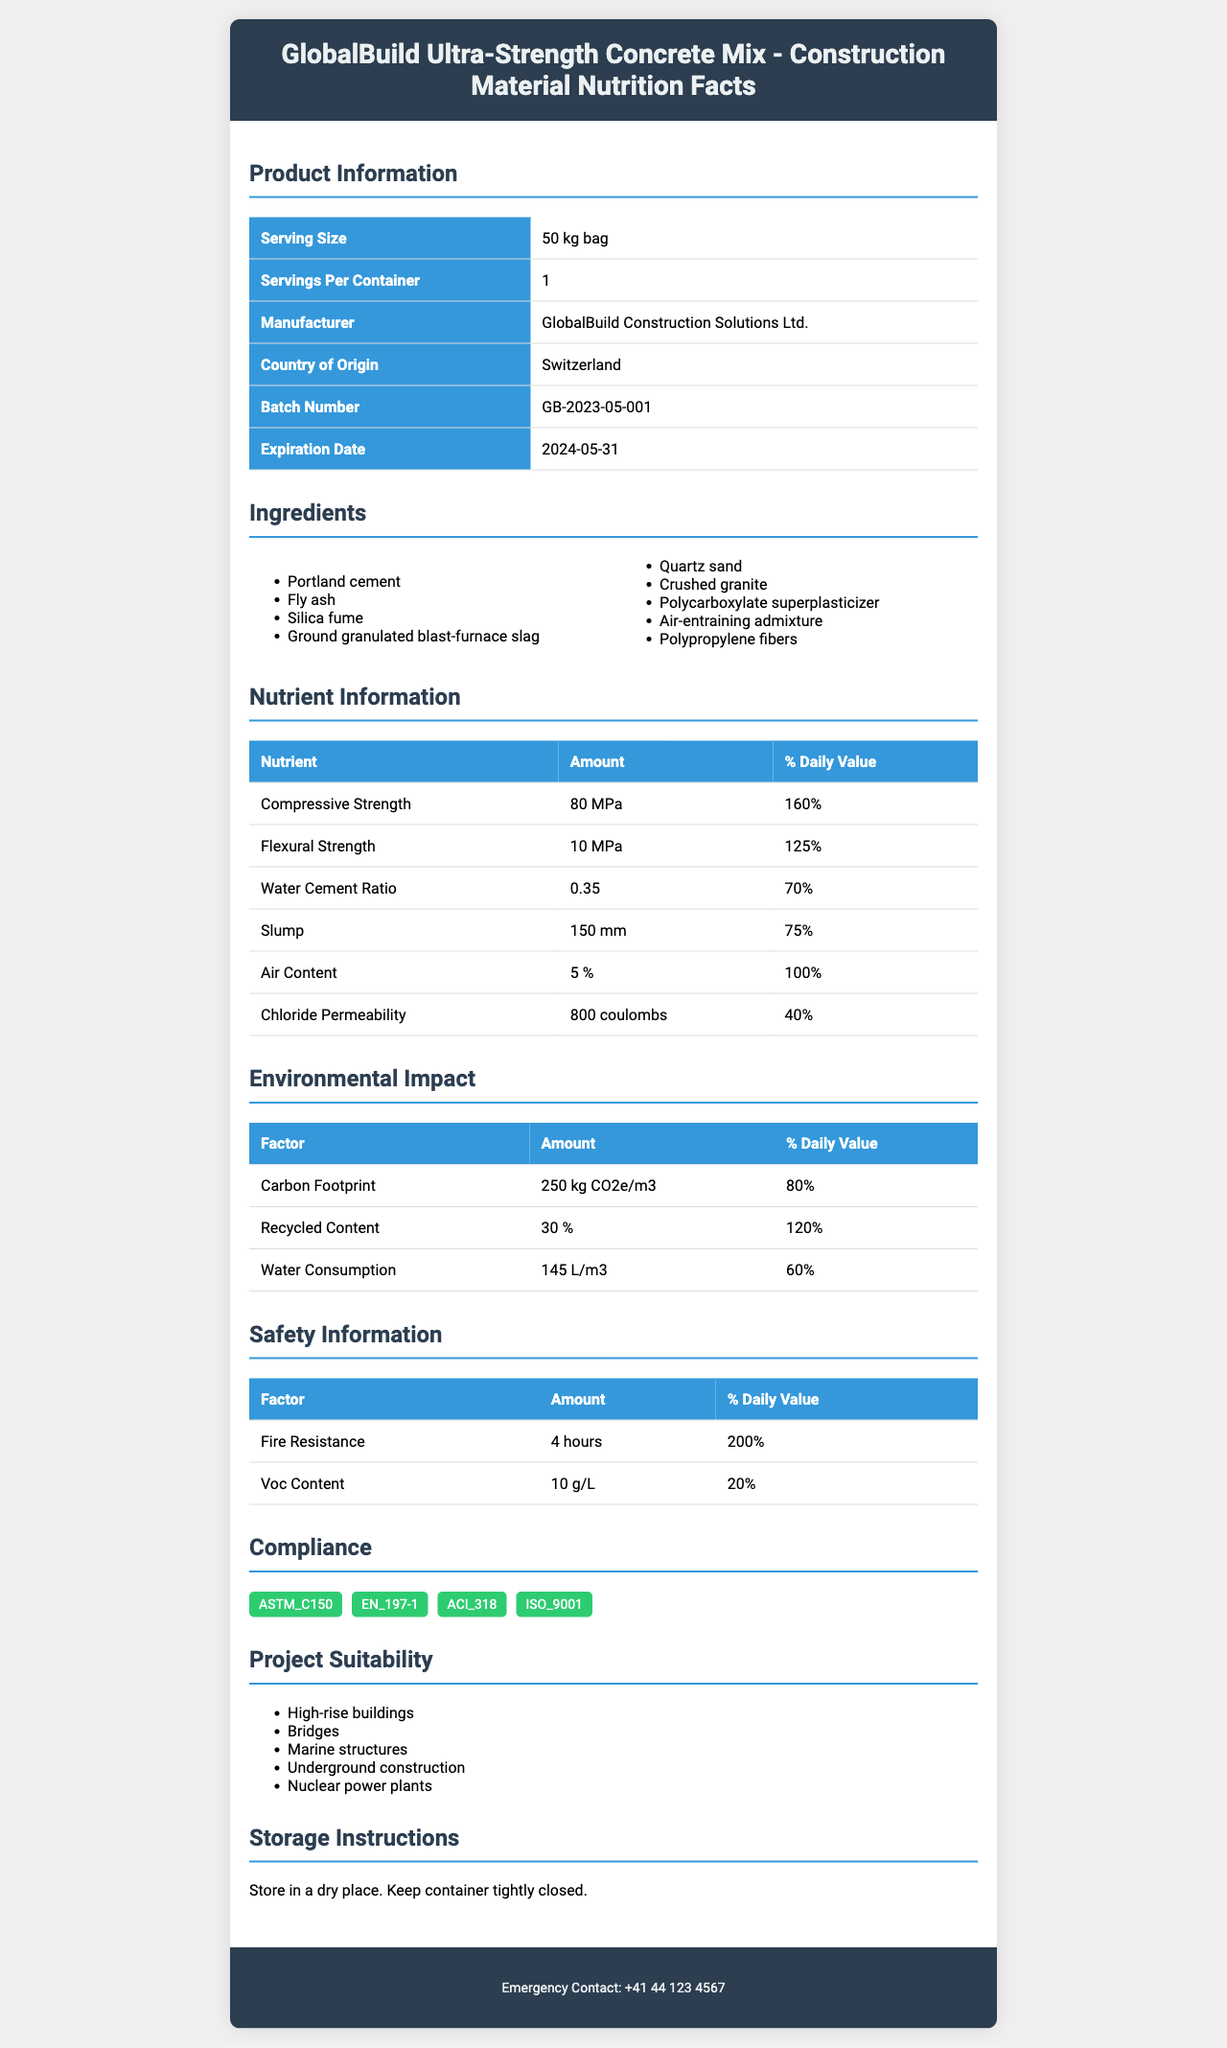what is the serving size of the GlobalBuild Ultra-Strength Concrete Mix? The serving size is listed as "50 kg bag" in the product information section.
Answer: 50 kg bag how many servings are there per container? The document states that there is 1 serving per container.
Answer: 1 name three ingredients used in the GlobalBuild Ultra-Strength Concrete Mix. The document lists the ingredients, and three of them include Portland cement, Fly ash, and Silica fume.
Answer: Portland cement, Fly ash, Silica fume what is the compressive strength value and its unit? The compressive strength value is 80, and the unit is MPa as mentioned in the nutrient information section.
Answer: 80 MPa what is the batch number of the product? The batch number is listed as "GB-2023-05-001" in the product information section.
Answer: GB-2023-05-001 how much recycled content is there, and what percentage of the daily value does it represent? The recycled content is 30%, representing 120% of the daily value.
Answer: 30%, 120% which factors are included in the environmental impact section? These factors are listed under the environmental impact section.
Answer: Carbon footprint, Recycled content, Water consumption which of the following structures is NOT mentioned as suitable for this product? A. High-rise buildings B. Bridges C. Dams D. Marine structures Dams are not listed in the project suitability section, whereas high-rise buildings, bridges, and marine structures are mentioned.
Answer: C. Dams which one of the following standards does the product comply with? i. ASTM_C150 ii. EN_197-1 iii. ACI_318 iv. All of the above The document shows that the product complies with ASTM_C150, EN_197-1, ACI_318, and ISO_9001.
Answer: iv. All of the above is the product fire-resistant? The safety information section mentions that the product has fire resistance of 4 hours with a 200% daily value.
Answer: Yes summarize the main information presented in the document. The document is comprehensive, covering multiple key aspects such as serving size, ingredients, nutrient values like compressive and flexural strength, environmental impact factors like carbon footprint and water consumption, safety details like fire resistance, compliance with various industry standards, and recommended usage for different construction projects.
Answer: The GlobalBuild Ultra-Strength Concrete Mix document provides detailed information about the product, including serving size, ingredients, nutrient values, environmental impact, safety information, compliance with standards, project suitability, manufacturing details, and emergency contact information. what is the water-to-cement ratio? The water-to-cement ratio is listed as 0.35 in the nutrient information section.
Answer: 0.35 how many hours of fire resistance does the product have? The safety information section indicates the product has 4 hours of fire resistance.
Answer: 4 hours where should the bags of GlobalBuild Ultra-Strength Concrete Mix be stored? The storage instructions clearly state to store in a dry place and keep the container tightly closed.
Answer: In a dry place, keep container tightly closed who is the manufacturer of this product? According to the product information section, the manufacturer is GlobalBuild Construction Solutions Ltd.
Answer: GlobalBuild Construction Solutions Ltd. what is the expiration date of the product? The expiration date is listed as "2024-05-31" in the product information section.
Answer: 2024-05-31 what is the exact percentage of daily value for VOC content? The exact percentage daily value for VOC content is listed as 20% in the safety information section.
Answer: 20% how does the compressive strength daily value relate to other nutrient daily values in the document? The compressive strength daily value is higher compared to flexural strength (125%), water-cement ratio (70%), slump (75%), air content (100%), and chloride permeability (40%).
Answer: It is the highest daily value percentage, at 160%. calculate the total environmental impact daily value percentages. Adding the daily value percentages of carbon footprint (80%), recycled content (120%), and water consumption (60%), the total environmental impact daily value is 260%.
Answer: 260% what is the emergency contact number for GlobalBuild Construction Solutions Ltd.? The emergency contact number is listed as "+41 44 123 4567" in the footer of the document.
Answer: +41 44 123 4567 what is the nutritional value of the mix in terms of Gibbs free energy? The document does not provide any information regarding the Gibbs free energy of the mix.
Answer: Not enough information 